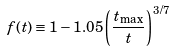<formula> <loc_0><loc_0><loc_500><loc_500>f ( t ) \equiv 1 - 1 . 0 5 \left ( \frac { t _ { \max } } { t } \right ) ^ { 3 / 7 }</formula> 